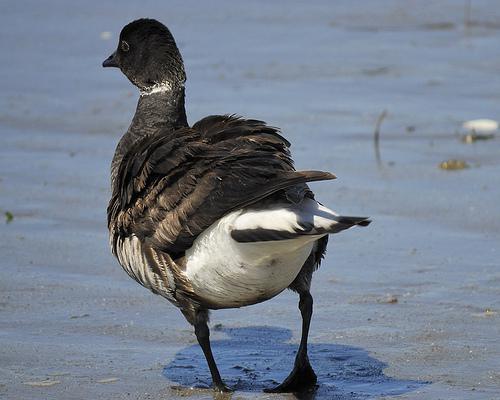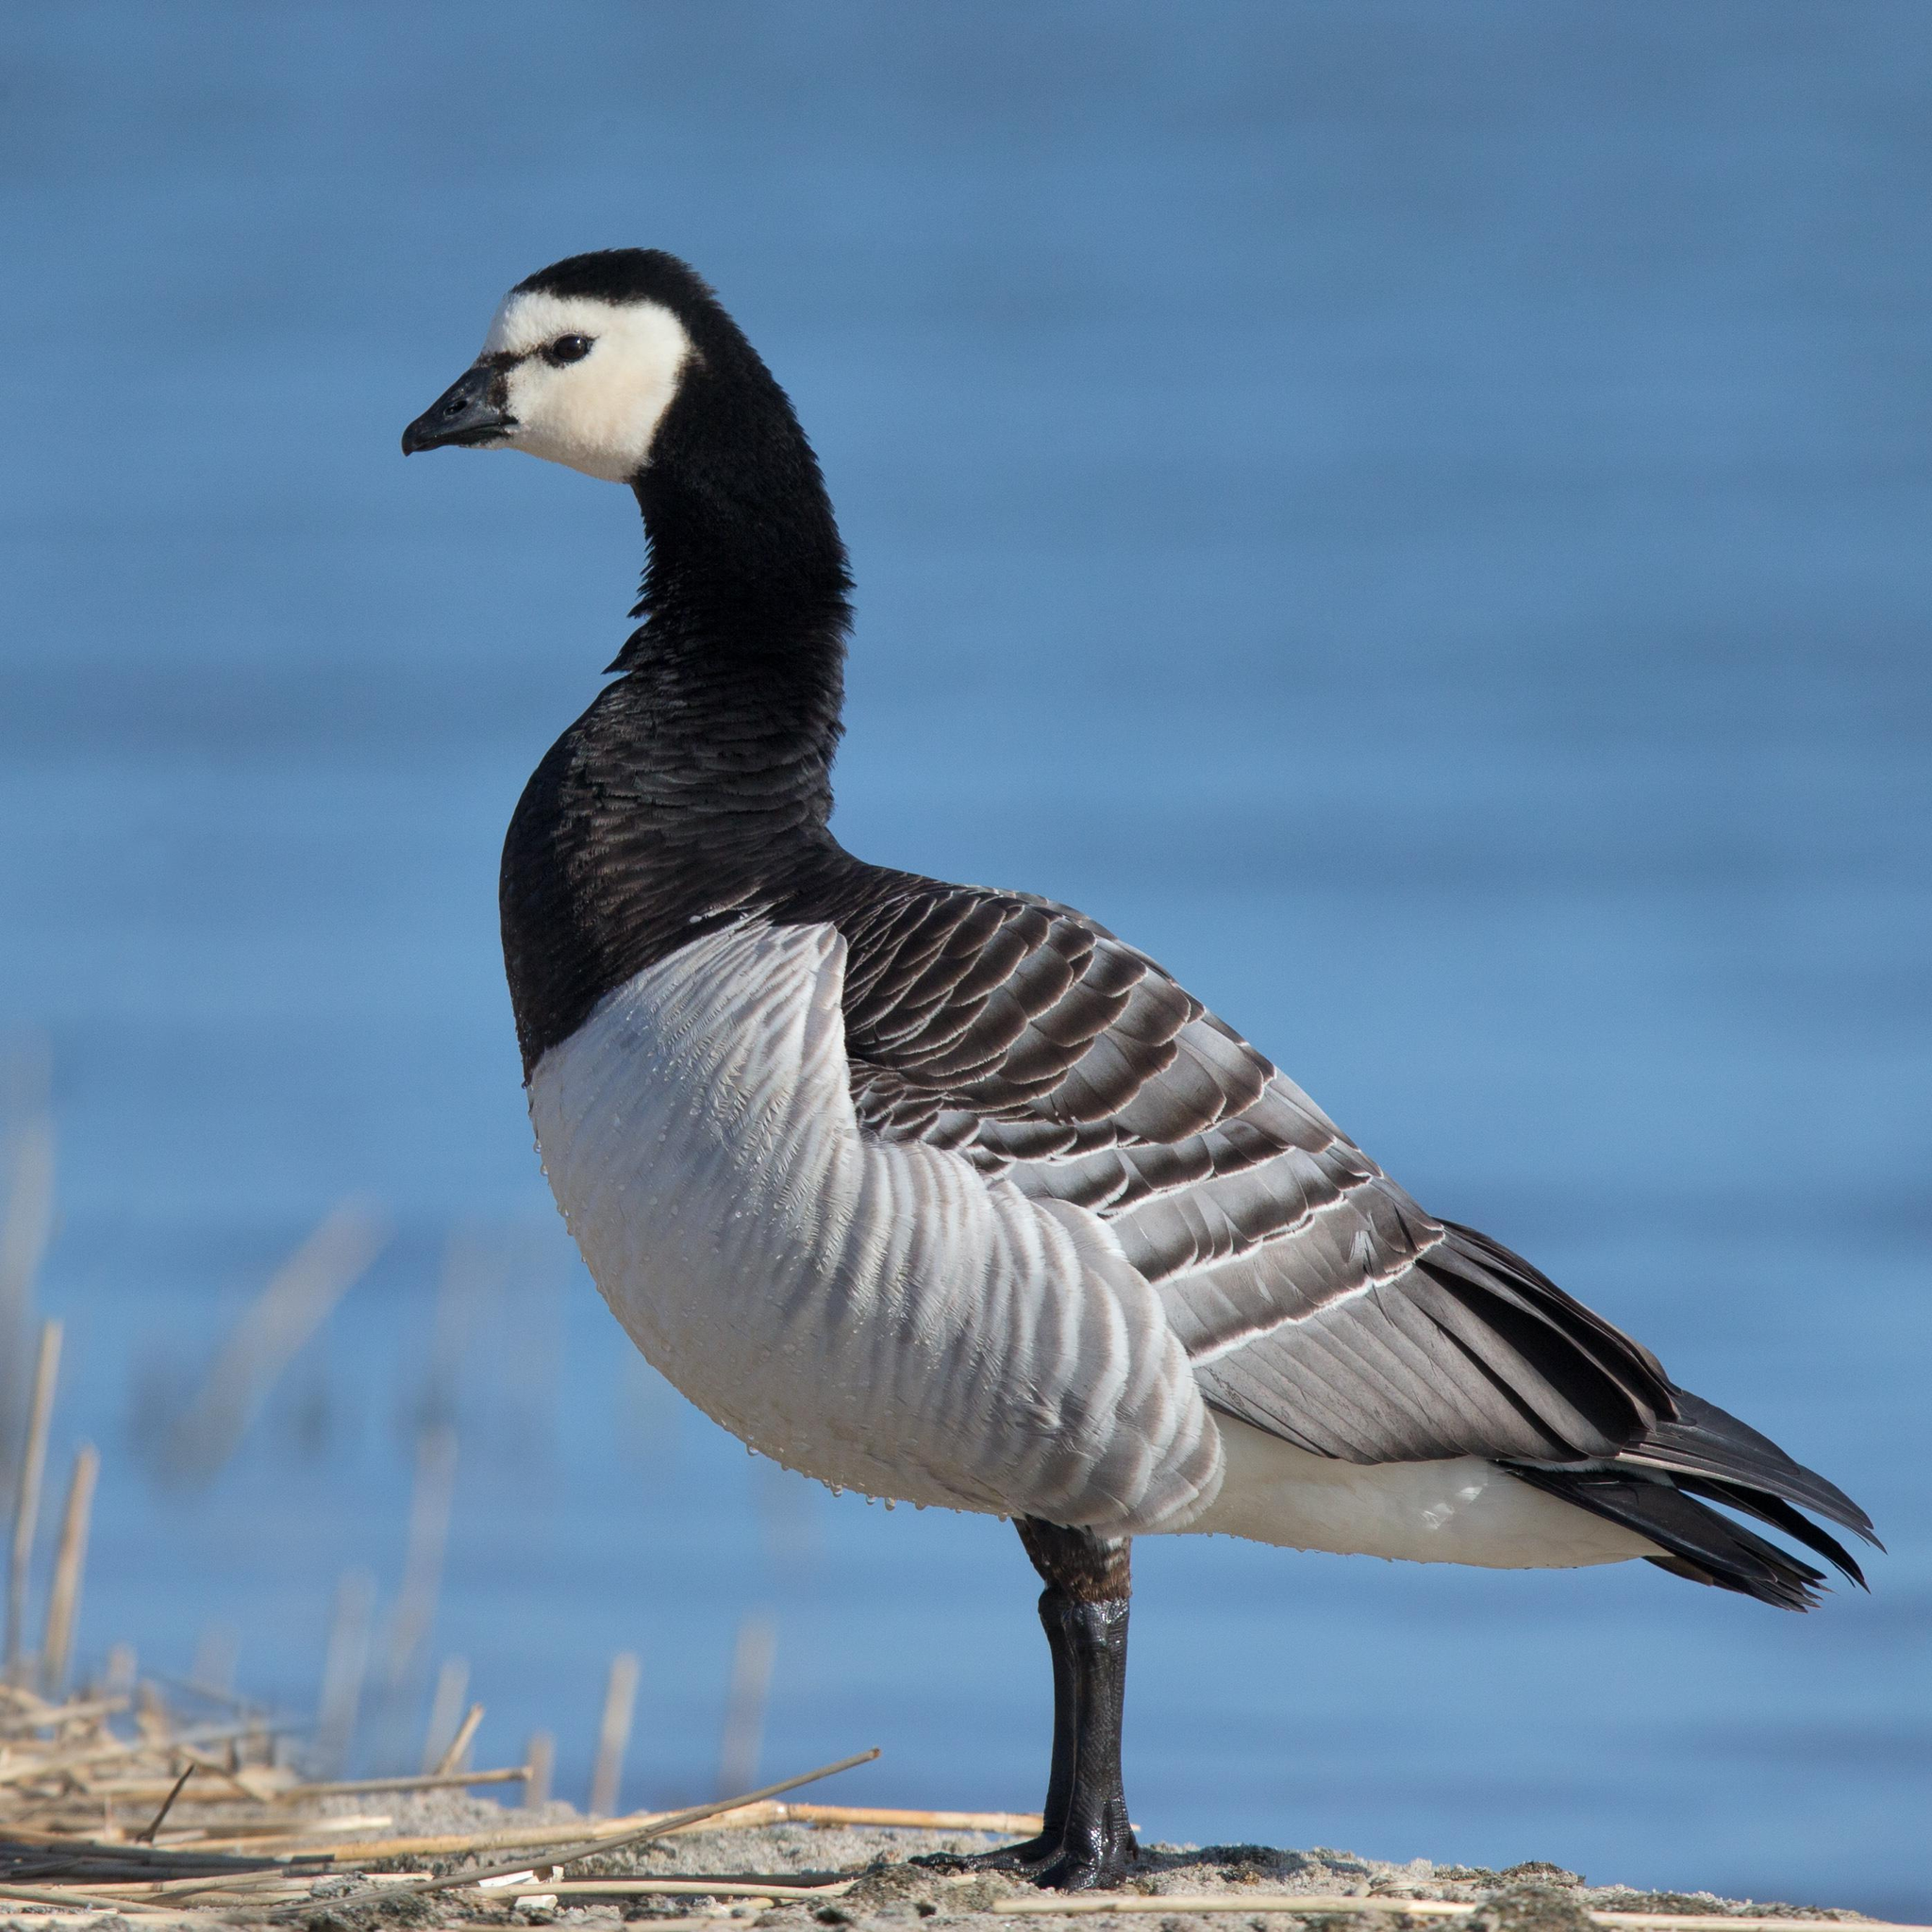The first image is the image on the left, the second image is the image on the right. Assess this claim about the two images: "the bird on the left faces right and the bird on the right faces left". Correct or not? Answer yes or no. No. 